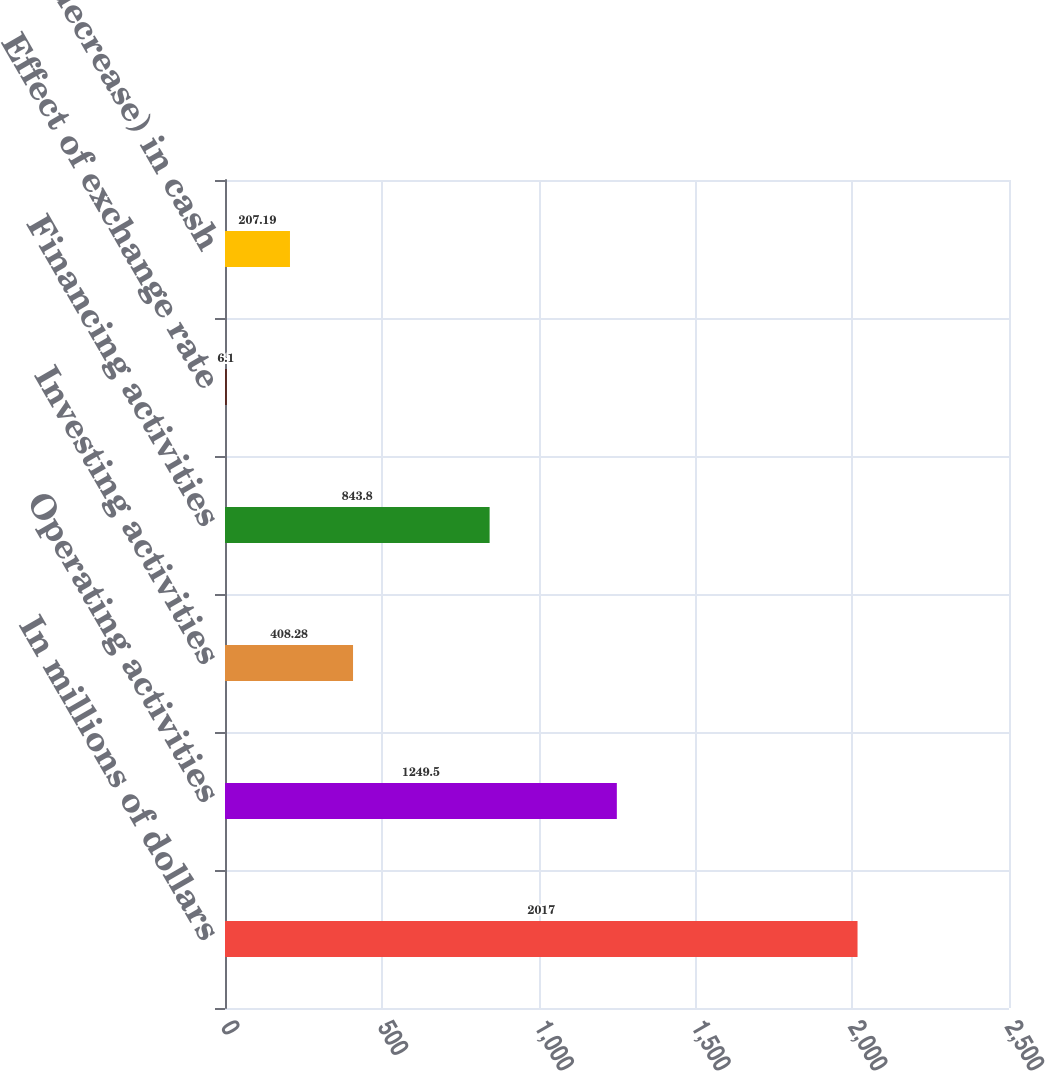Convert chart to OTSL. <chart><loc_0><loc_0><loc_500><loc_500><bar_chart><fcel>In millions of dollars<fcel>Operating activities<fcel>Investing activities<fcel>Financing activities<fcel>Effect of exchange rate<fcel>Increase (decrease) in cash<nl><fcel>2017<fcel>1249.5<fcel>408.28<fcel>843.8<fcel>6.1<fcel>207.19<nl></chart> 